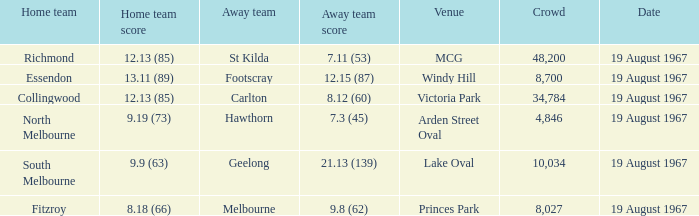Could you parse the entire table? {'header': ['Home team', 'Home team score', 'Away team', 'Away team score', 'Venue', 'Crowd', 'Date'], 'rows': [['Richmond', '12.13 (85)', 'St Kilda', '7.11 (53)', 'MCG', '48,200', '19 August 1967'], ['Essendon', '13.11 (89)', 'Footscray', '12.15 (87)', 'Windy Hill', '8,700', '19 August 1967'], ['Collingwood', '12.13 (85)', 'Carlton', '8.12 (60)', 'Victoria Park', '34,784', '19 August 1967'], ['North Melbourne', '9.19 (73)', 'Hawthorn', '7.3 (45)', 'Arden Street Oval', '4,846', '19 August 1967'], ['South Melbourne', '9.9 (63)', 'Geelong', '21.13 (139)', 'Lake Oval', '10,034', '19 August 1967'], ['Fitzroy', '8.18 (66)', 'Melbourne', '9.8 (62)', 'Princes Park', '8,027', '19 August 1967']]} When the venue was lake oval what did the home team score? 9.9 (63). 